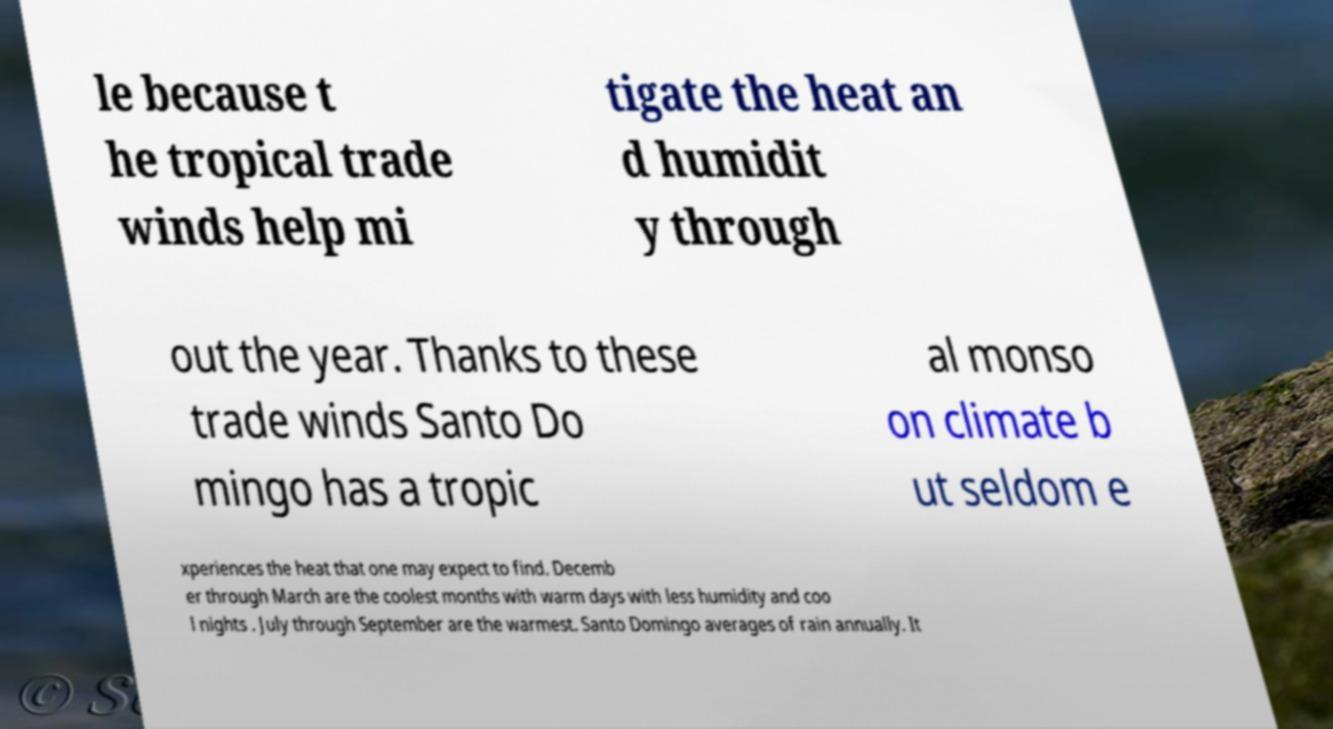I need the written content from this picture converted into text. Can you do that? le because t he tropical trade winds help mi tigate the heat an d humidit y through out the year. Thanks to these trade winds Santo Do mingo has a tropic al monso on climate b ut seldom e xperiences the heat that one may expect to find. Decemb er through March are the coolest months with warm days with less humidity and coo l nights . July through September are the warmest. Santo Domingo averages of rain annually. It 